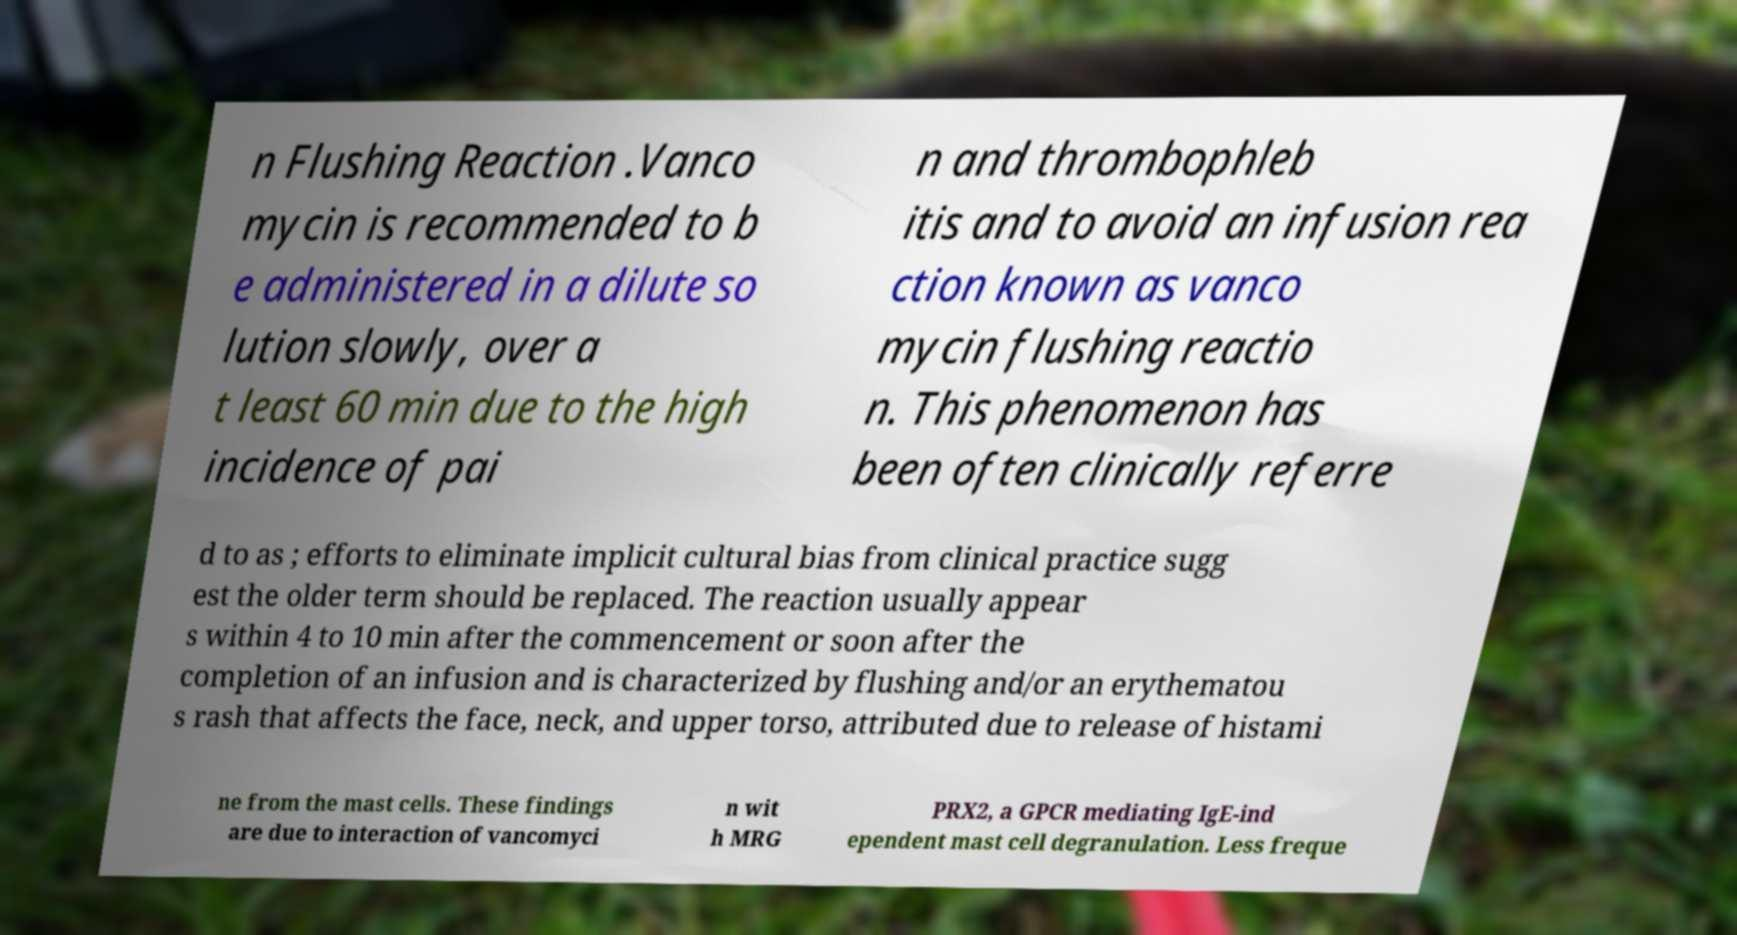What messages or text are displayed in this image? I need them in a readable, typed format. n Flushing Reaction .Vanco mycin is recommended to b e administered in a dilute so lution slowly, over a t least 60 min due to the high incidence of pai n and thrombophleb itis and to avoid an infusion rea ction known as vanco mycin flushing reactio n. This phenomenon has been often clinically referre d to as ; efforts to eliminate implicit cultural bias from clinical practice sugg est the older term should be replaced. The reaction usually appear s within 4 to 10 min after the commencement or soon after the completion of an infusion and is characterized by flushing and/or an erythematou s rash that affects the face, neck, and upper torso, attributed due to release of histami ne from the mast cells. These findings are due to interaction of vancomyci n wit h MRG PRX2, a GPCR mediating IgE-ind ependent mast cell degranulation. Less freque 